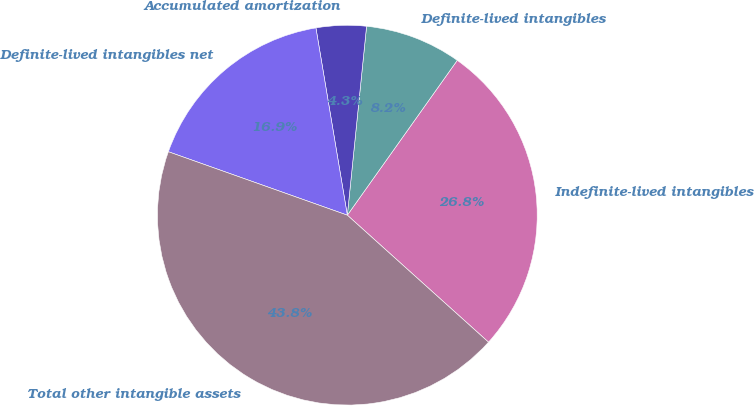<chart> <loc_0><loc_0><loc_500><loc_500><pie_chart><fcel>Indefinite-lived intangibles<fcel>Definite-lived intangibles<fcel>Accumulated amortization<fcel>Definite-lived intangibles net<fcel>Total other intangible assets<nl><fcel>26.83%<fcel>8.21%<fcel>4.26%<fcel>16.93%<fcel>43.76%<nl></chart> 